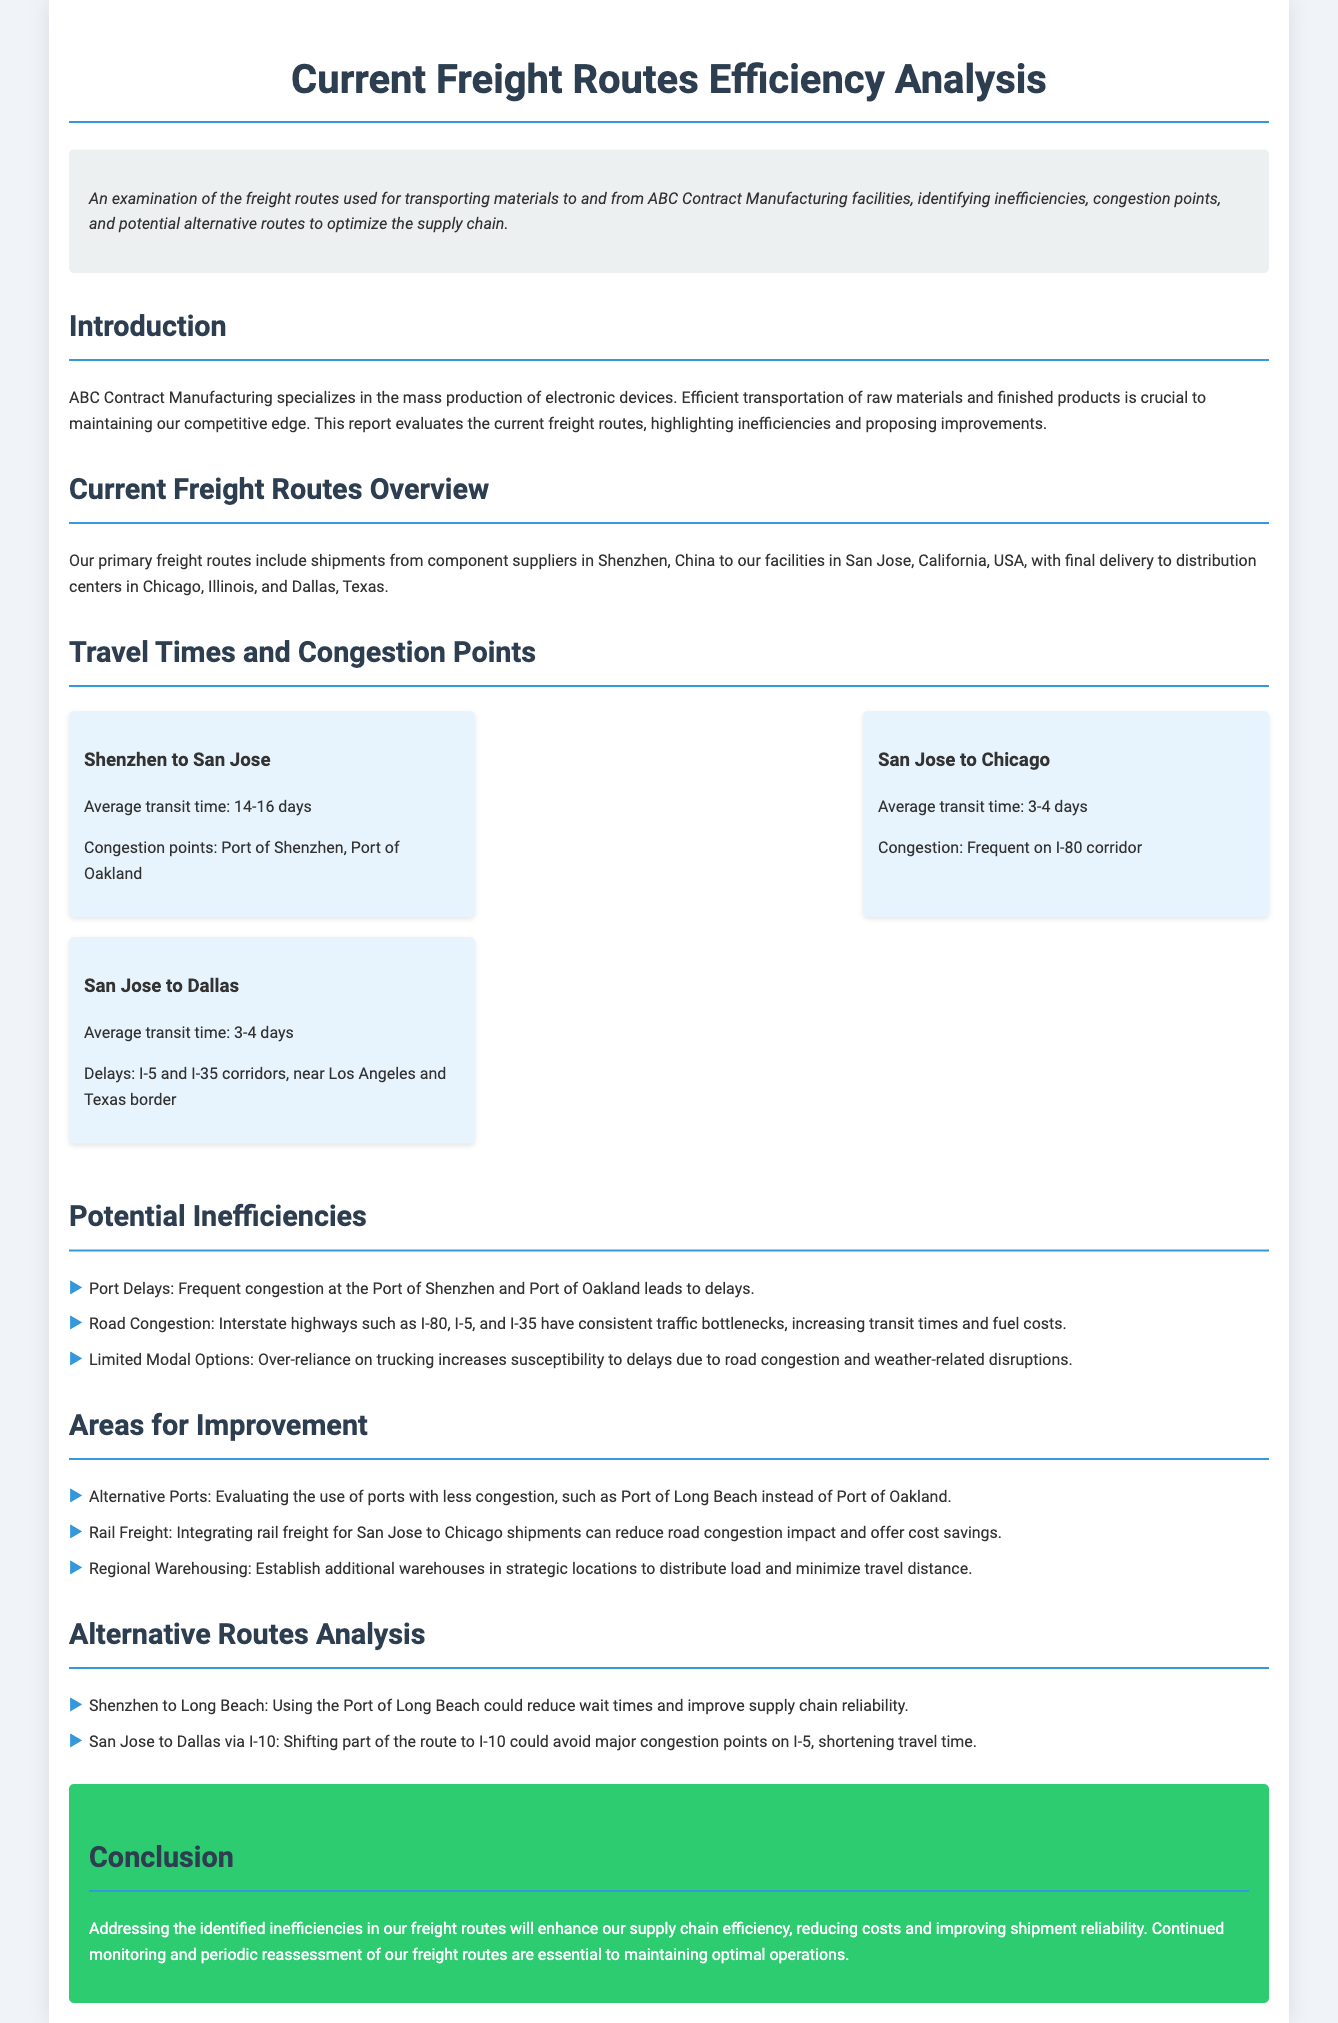What are the average transit times from Shenzhen to San Jose? The information on transit times between Shenzhen and San Jose is provided in the section on Travel Times and Congestion Points.
Answer: 14-16 days What is a proposed alternative port to reduce delays? The document suggests alternatives in the Areas for Improvement section, focusing on ports with less congestion.
Answer: Port of Long Beach What highway experiences frequent congestion when shipping from San Jose to Chicago? The congestion on highways is detailed in the Travel Times and Congestion Points section, specifying routes facing issues.
Answer: I-80 corridor How many days does it take on average to ship from San Jose to Dallas? The average time for this route is included in the travel times information.
Answer: 3-4 days What method is suggested to reduce road congestion impacts? The document recommends looking at alternatives in the Areas for Improvement section that address congestion.
Answer: Rail Freight What is a major congestion point for shipments from Shenzhen? This is indicated in the Travel Times and Congestion Points section, detailing known congestion locations.
Answer: Port of Shenzhen What are the two main locations for final delivery of products? The Delivery section provides clarity on where products are sent, which is essential for understanding the supply chain.
Answer: Chicago, Illinois and Dallas, Texas Which interstate is suggested as an alternative route for shipment between San Jose and Dallas? Alternative routes are discussed, offering solutions for efficient transport which include specific highways.
Answer: I-10 